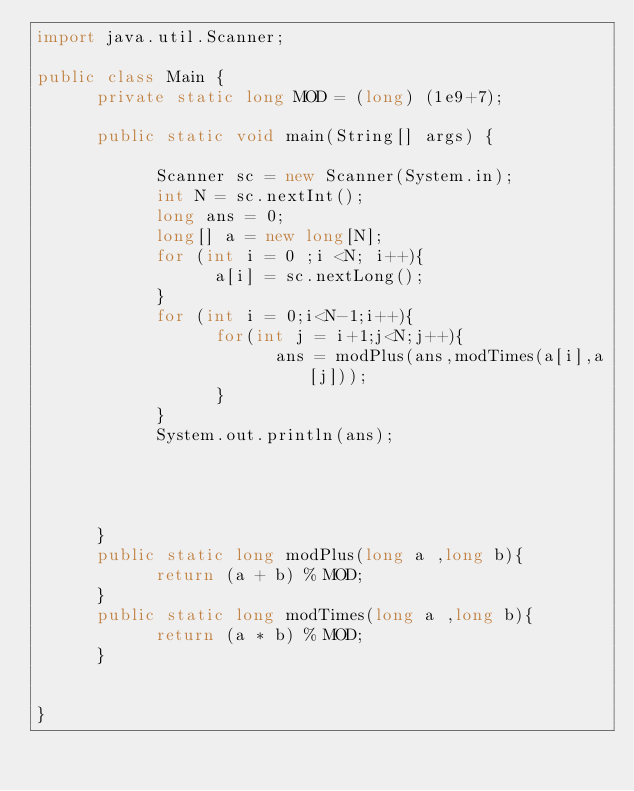<code> <loc_0><loc_0><loc_500><loc_500><_Java_>import java.util.Scanner;

public class Main {
      private static long MOD = (long) (1e9+7);

      public static void main(String[] args) {

            Scanner sc = new Scanner(System.in);
            int N = sc.nextInt();
            long ans = 0;
            long[] a = new long[N];
            for (int i = 0 ;i <N; i++){
                  a[i] = sc.nextLong();
            }
            for (int i = 0;i<N-1;i++){
                  for(int j = i+1;j<N;j++){
                        ans = modPlus(ans,modTimes(a[i],a[j]));
                  }
            }
            System.out.println(ans);




      }
      public static long modPlus(long a ,long b){
            return (a + b) % MOD;
      }
      public static long modTimes(long a ,long b){
            return (a * b) % MOD;
      }


}
</code> 